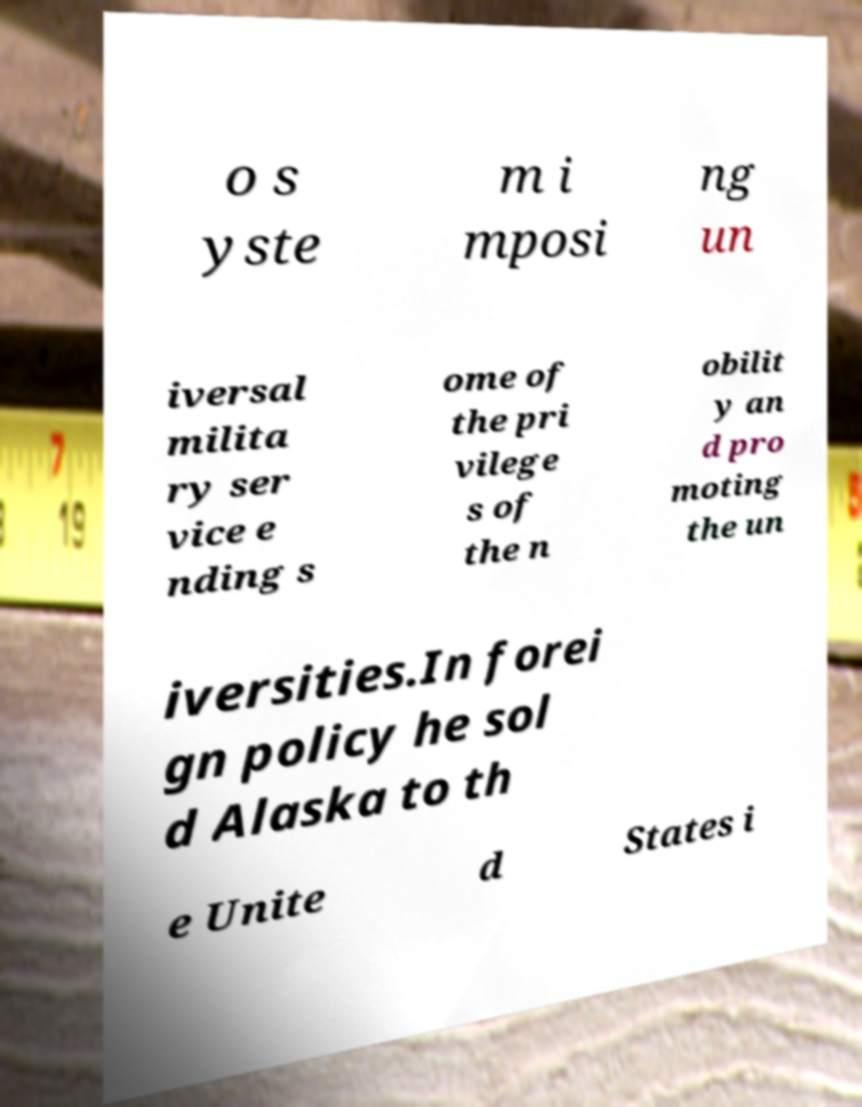What messages or text are displayed in this image? I need them in a readable, typed format. o s yste m i mposi ng un iversal milita ry ser vice e nding s ome of the pri vilege s of the n obilit y an d pro moting the un iversities.In forei gn policy he sol d Alaska to th e Unite d States i 